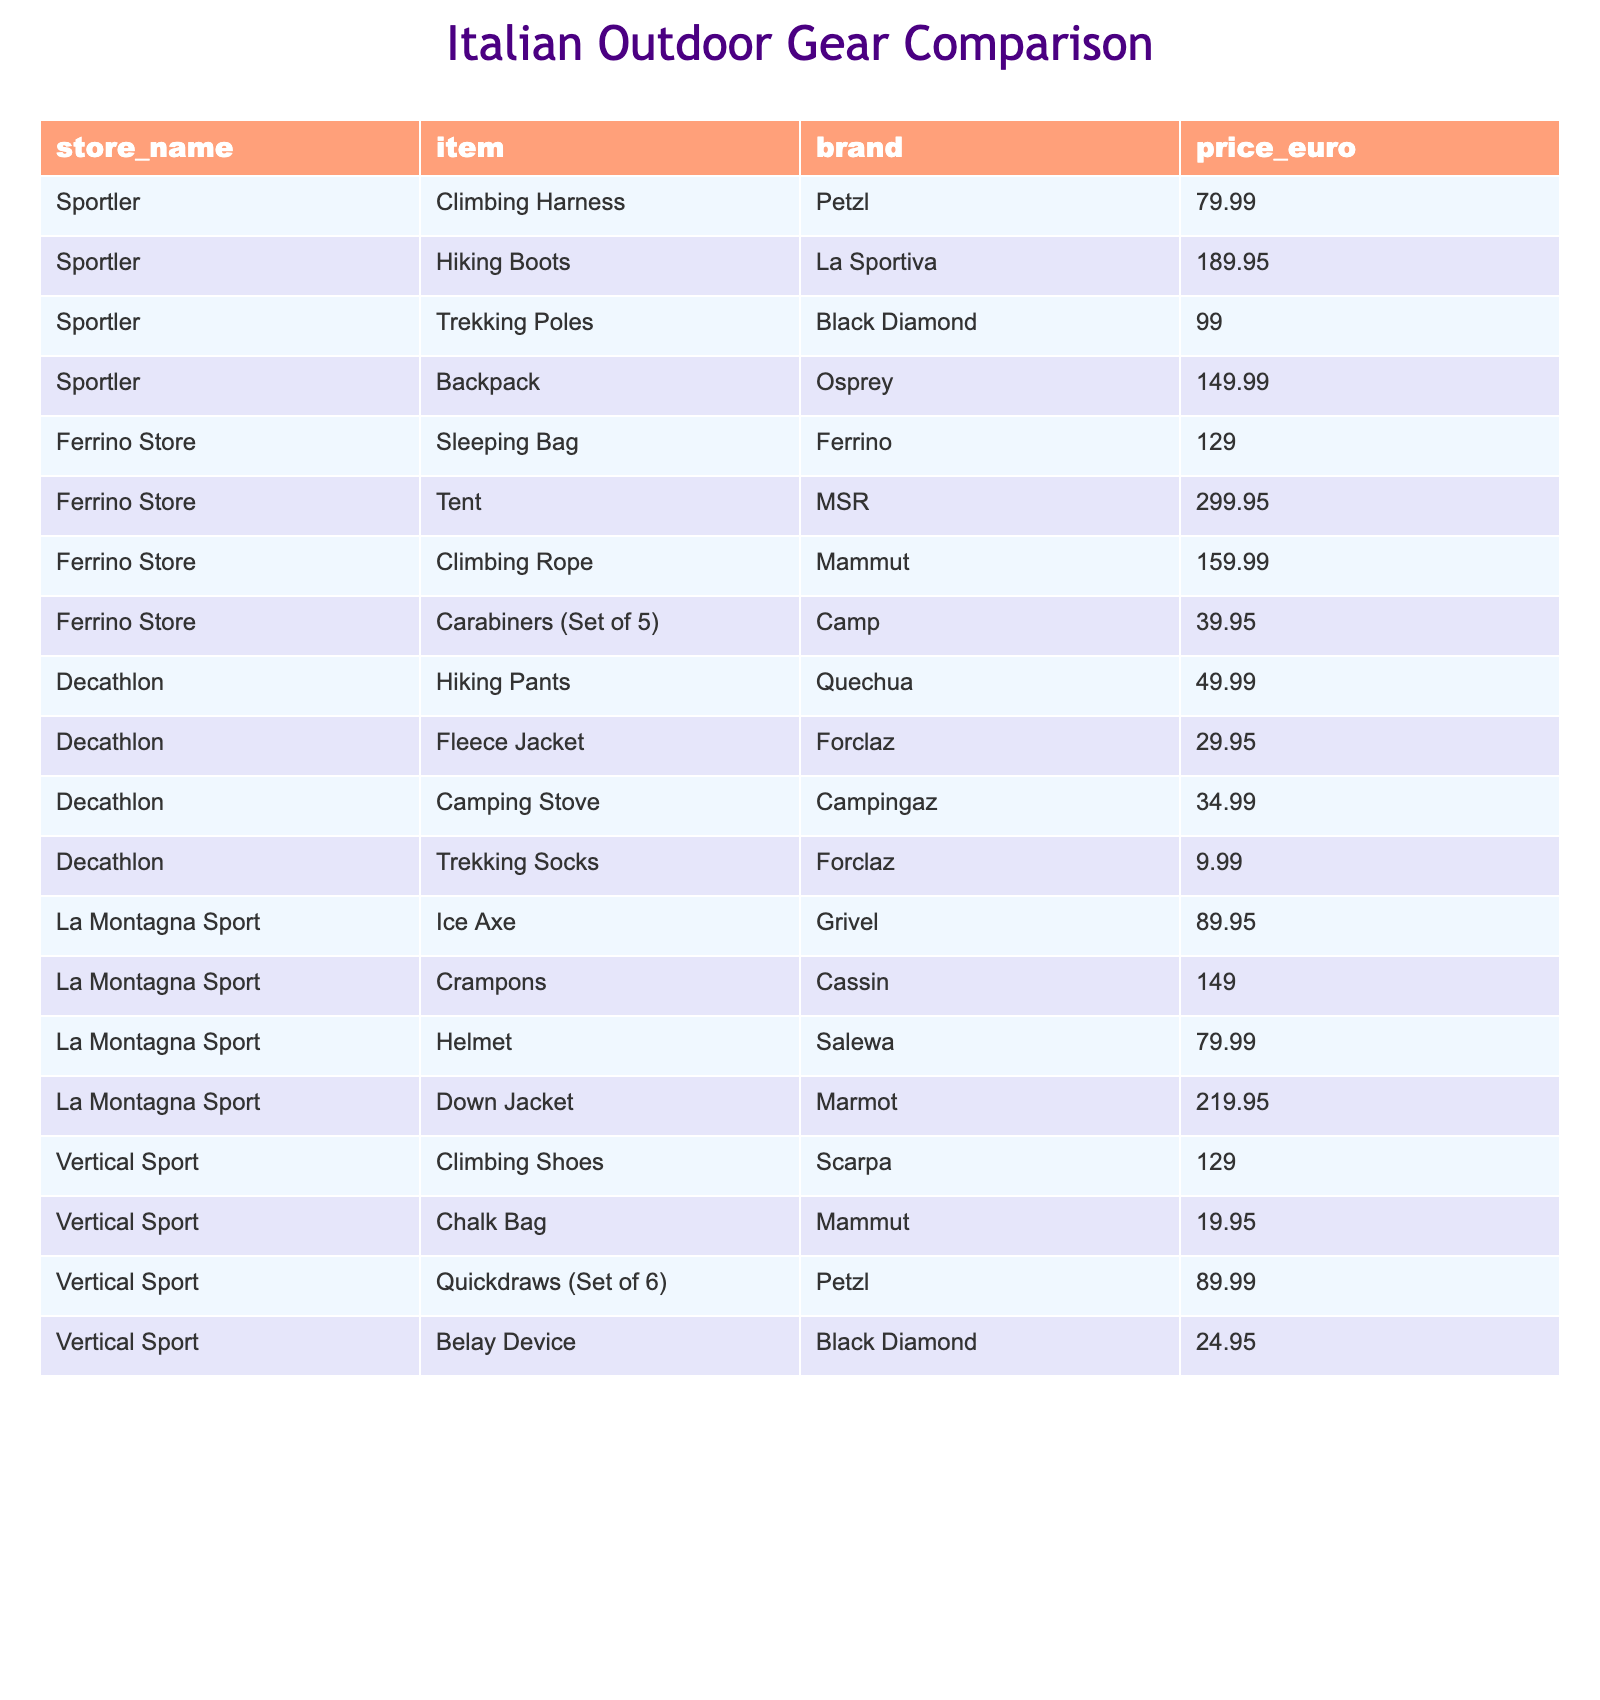What is the price of the Down Jacket offered by La Montagna Sport? The table directly shows that the Down Jacket from La Montagna Sport is priced at 219.95 euros.
Answer: 219.95 euros Which store offers the cheapest Trekking Poles? The table lists the Trekking Poles at Sportler for 99.00 euros, while no other prices for Trekking Poles are provided. Thus, Sportler has the cheapest option.
Answer: Sportler How much does a set of Carabiners (Set of 5) cost? The table indicates that the Carabiners (Set of 5) from Ferrino Store are priced at 39.95 euros.
Answer: 39.95 euros What is the total cost of purchasing both a Climbing Harness and a Belay Device? The Climbing Harness costs 79.99 euros and the Belay Device costs 24.95 euros. To find the total, add these amounts: 79.99 + 24.95 = 104.94 euros.
Answer: 104.94 euros How many items are priced greater than 200 euros? The items listed are a Down Jacket at 219.95 euros and a Tent at 299.95 euros. Both are above 200 euros, totaling two items.
Answer: 2 items Which brand has the most expensive item on the list? The Tent by MSR costs 299.95 euros, making it the most expensive item in the table. No other items exceed this price.
Answer: MSR What is the average price of all items offered by Decathlon? The prices of Decathlon items are: 49.99, 29.95, 34.99, and 9.99 euros. Summing these gives 124.92 euros, and dividing by the number of items (4) results in an average of 31.23 euros.
Answer: 31.23 euros Is there an item from Vertical Sport that costs less than 30 euros? The table shows the Chalk Bag from Vertical Sport costs 19.95 euros, which is less than 30 euros. Therefore, the statement is true.
Answer: Yes What is the price difference between the Ice Axe and the Crampons in La Montagna Sport? The Ice Axe costs 89.95 euros, and the Crampons cost 149.00 euros. The difference is 149.00 - 89.95 = 59.05 euros.
Answer: 59.05 euros How many items listed in the table are from the brand Petzl? The table shows two items from Petzl: the Climbing Harness and the Quickdraws (Set of 6). Thus, there are two items from this brand.
Answer: 2 items 